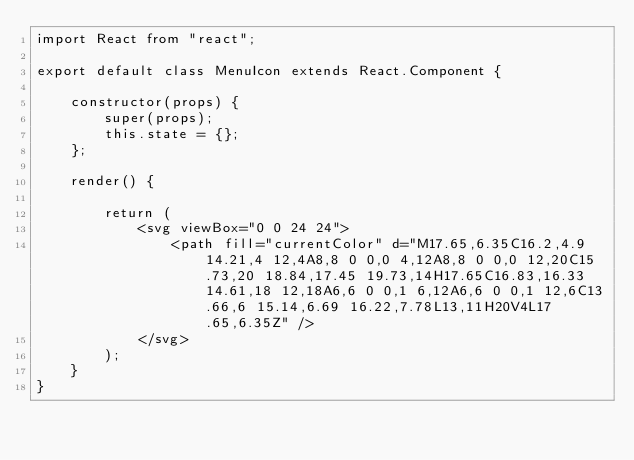Convert code to text. <code><loc_0><loc_0><loc_500><loc_500><_JavaScript_>import React from "react";

export default class MenuIcon extends React.Component {

    constructor(props) {
        super(props);
        this.state = {};
    };

    render() {

        return (
            <svg viewBox="0 0 24 24">
                <path fill="currentColor" d="M17.65,6.35C16.2,4.9 14.21,4 12,4A8,8 0 0,0 4,12A8,8 0 0,0 12,20C15.73,20 18.84,17.45 19.73,14H17.65C16.83,16.33 14.61,18 12,18A6,6 0 0,1 6,12A6,6 0 0,1 12,6C13.66,6 15.14,6.69 16.22,7.78L13,11H20V4L17.65,6.35Z" />
            </svg>
        );
    }
}</code> 